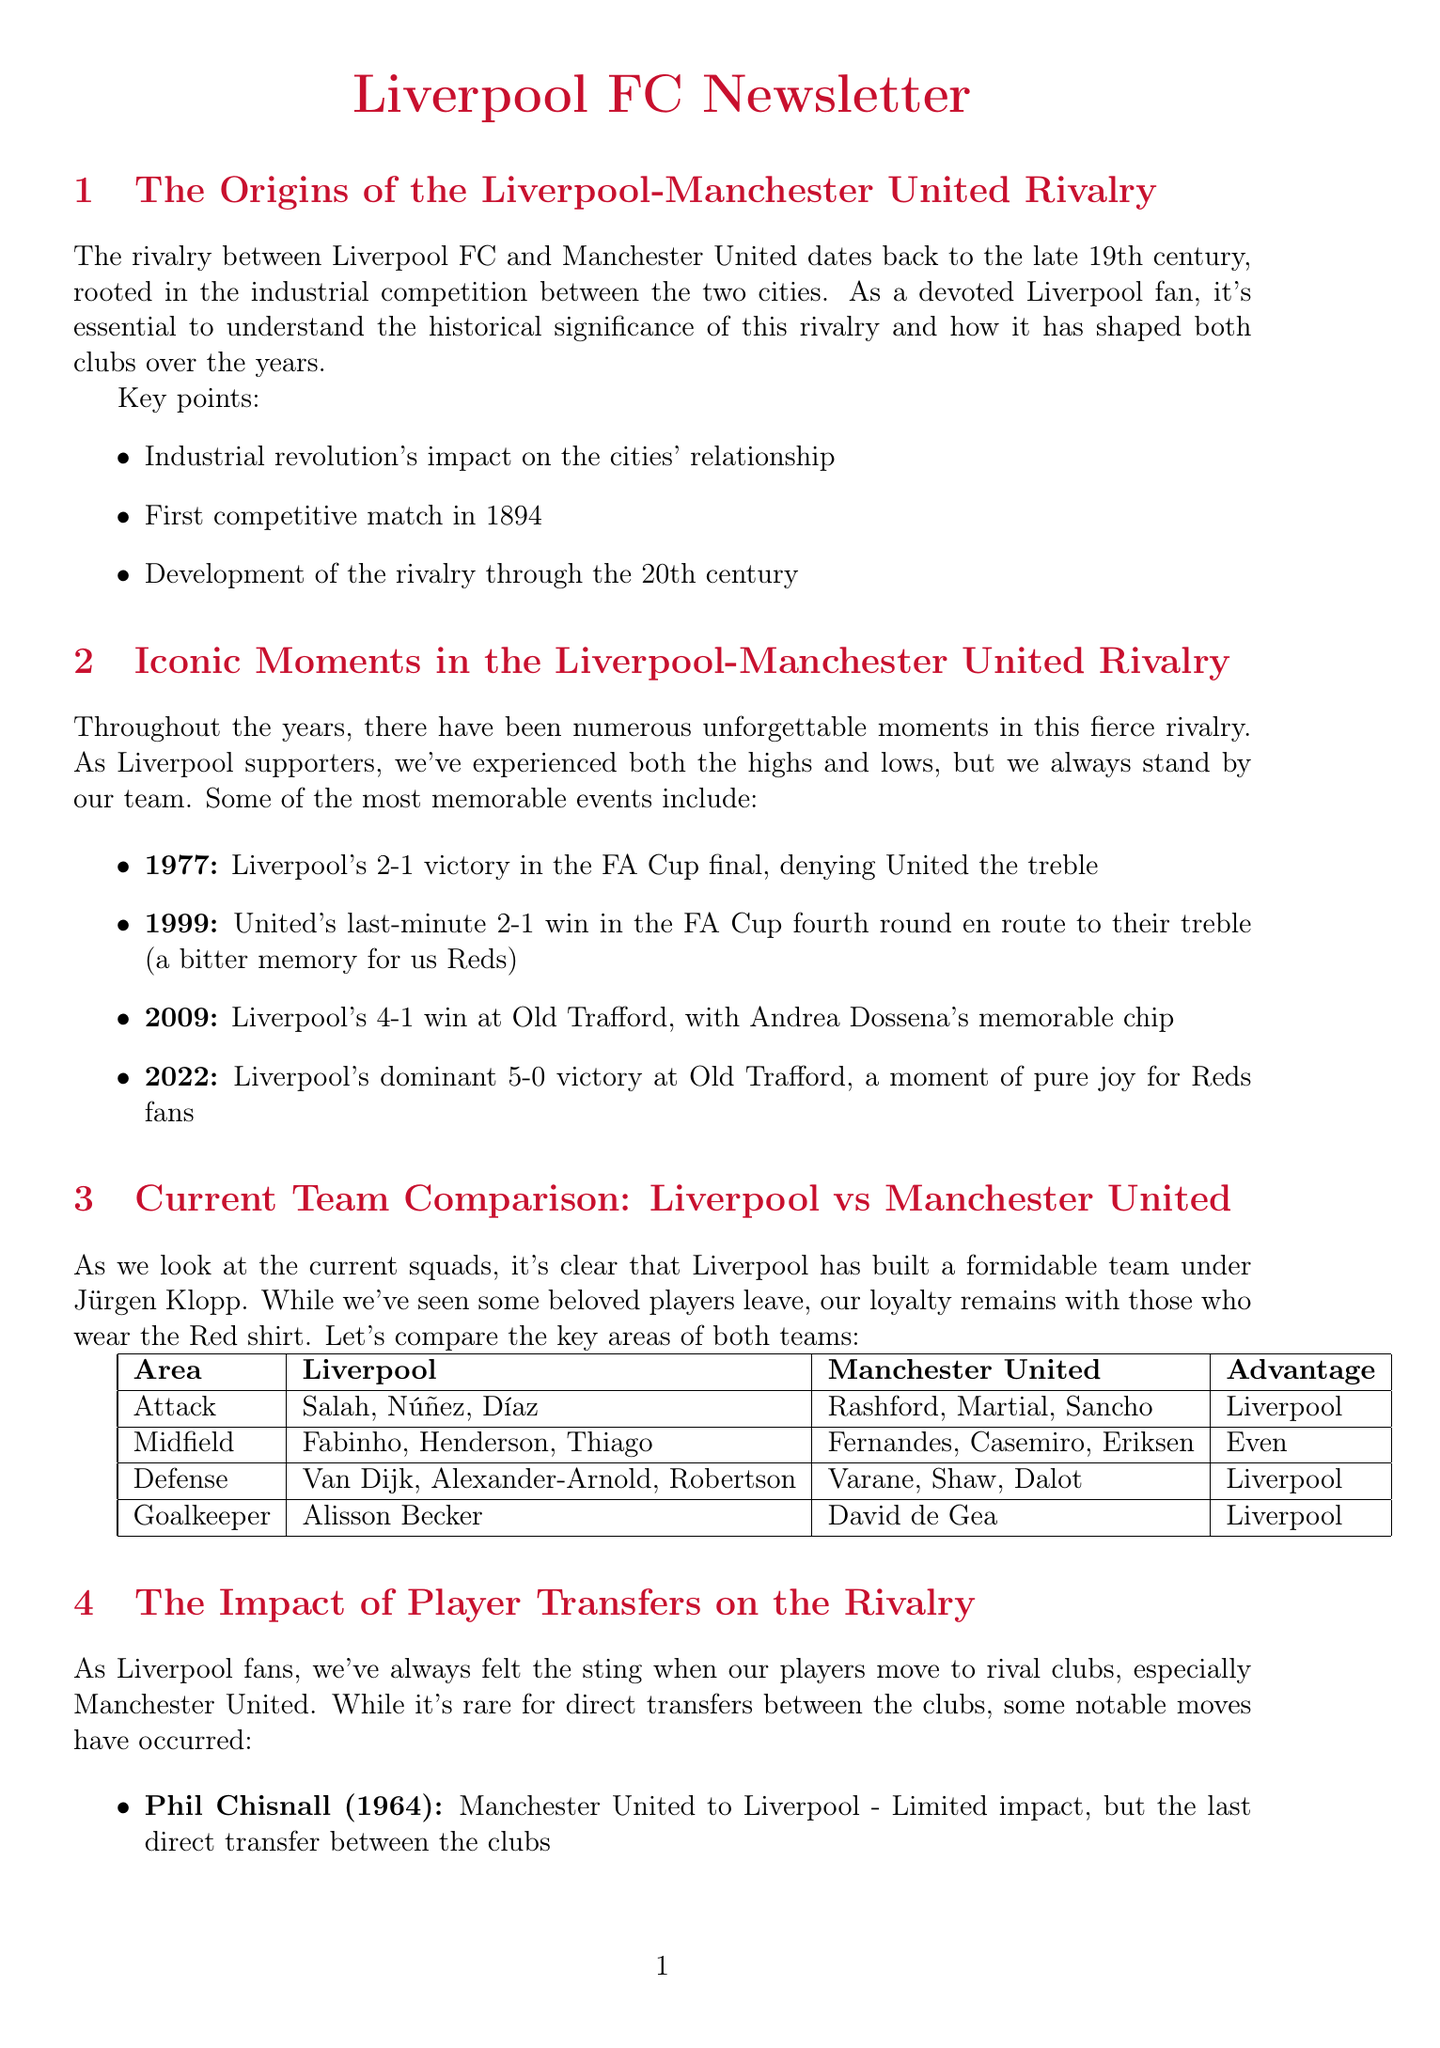What year did the first competitive match occur between Liverpool and Manchester United? The document states that the first competitive match took place in 1894.
Answer: 1894 What was the result of the 1977 FA Cup final between Liverpool and Manchester United? According to the document, Liverpool won the match 2-1, denying United the treble.
Answer: 2-1 Who is Liverpool's current goalkeeper mentioned in the comparison? The document lists Alisson Becker as Liverpool's goalkeeper in the comparison section.
Answer: Alisson Becker Which player transferred from Newcastle to Manchester United? The document mentions Michael Owen as the player who made this transfer in 2009.
Answer: Michael Owen What is noted as a reason for feeling betrayal by Liverpool fans regarding player transfers? The document explains that fans feel a sense of betrayal when players join rival clubs.
Answer: Betrayal In which year did Liverpool achieve a 5-0 victory at Old Trafford? The document states that this memorable moment occurred in 2022.
Answer: 2022 Which area of the current team comparison is labeled as "Even"? The document identifies the Midfield area as having strong options for both teams, hence marked as "Even."
Answer: Midfield What key point about the future rivalry is highlighted in the document? The document points out that both clubs continue to compete for domestic and European honors.
Answer: Compete for honors What influence is mentioned regarding the future of the rivalry? The document mentions the influence of managers Jürgen Klopp and Erik ten Hag as significant to the rivalry's future.
Answer: Managers' influence 